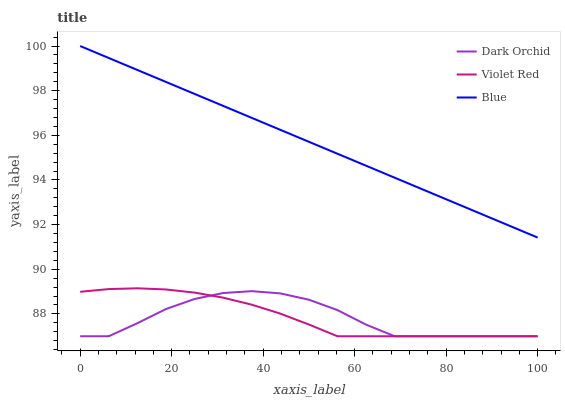Does Dark Orchid have the minimum area under the curve?
Answer yes or no. Yes. Does Blue have the maximum area under the curve?
Answer yes or no. Yes. Does Violet Red have the minimum area under the curve?
Answer yes or no. No. Does Violet Red have the maximum area under the curve?
Answer yes or no. No. Is Blue the smoothest?
Answer yes or no. Yes. Is Dark Orchid the roughest?
Answer yes or no. Yes. Is Violet Red the smoothest?
Answer yes or no. No. Is Violet Red the roughest?
Answer yes or no. No. Does Violet Red have the lowest value?
Answer yes or no. Yes. Does Blue have the highest value?
Answer yes or no. Yes. Does Violet Red have the highest value?
Answer yes or no. No. Is Dark Orchid less than Blue?
Answer yes or no. Yes. Is Blue greater than Violet Red?
Answer yes or no. Yes. Does Dark Orchid intersect Violet Red?
Answer yes or no. Yes. Is Dark Orchid less than Violet Red?
Answer yes or no. No. Is Dark Orchid greater than Violet Red?
Answer yes or no. No. Does Dark Orchid intersect Blue?
Answer yes or no. No. 